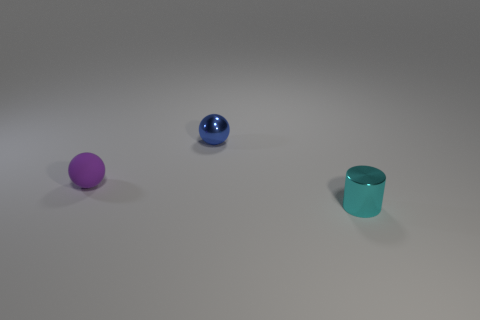Add 1 tiny yellow cubes. How many objects exist? 4 Subtract all cylinders. How many objects are left? 2 Add 2 gray metallic objects. How many gray metallic objects exist? 2 Subtract 0 yellow balls. How many objects are left? 3 Subtract all large blue matte cylinders. Subtract all small cyan shiny objects. How many objects are left? 2 Add 1 metallic cylinders. How many metallic cylinders are left? 2 